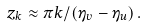Convert formula to latex. <formula><loc_0><loc_0><loc_500><loc_500>z _ { k } \approx \pi k / \left ( \eta _ { v } - \eta _ { u } \right ) .</formula> 